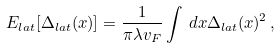Convert formula to latex. <formula><loc_0><loc_0><loc_500><loc_500>E _ { l a t } [ \Delta _ { l a t } ( x ) ] = \frac { 1 } { \pi \lambda v _ { F } } \int \, d x \Delta _ { l a t } ( x ) ^ { 2 } \, ,</formula> 